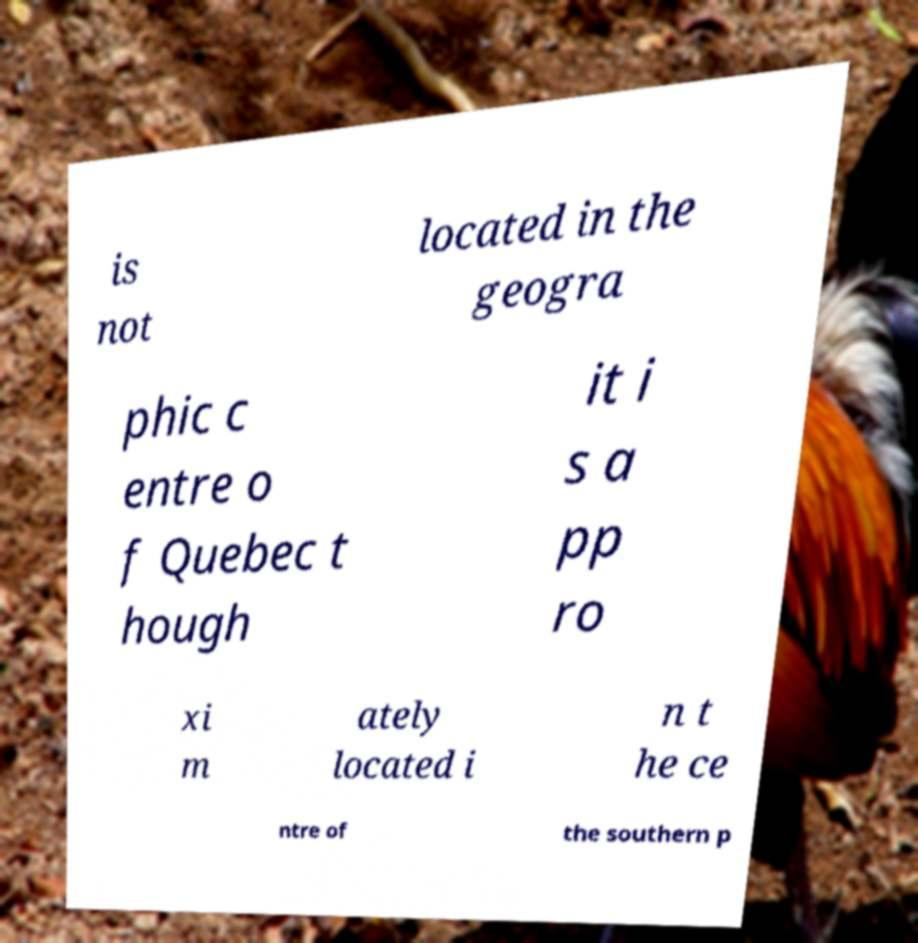Could you assist in decoding the text presented in this image and type it out clearly? is not located in the geogra phic c entre o f Quebec t hough it i s a pp ro xi m ately located i n t he ce ntre of the southern p 